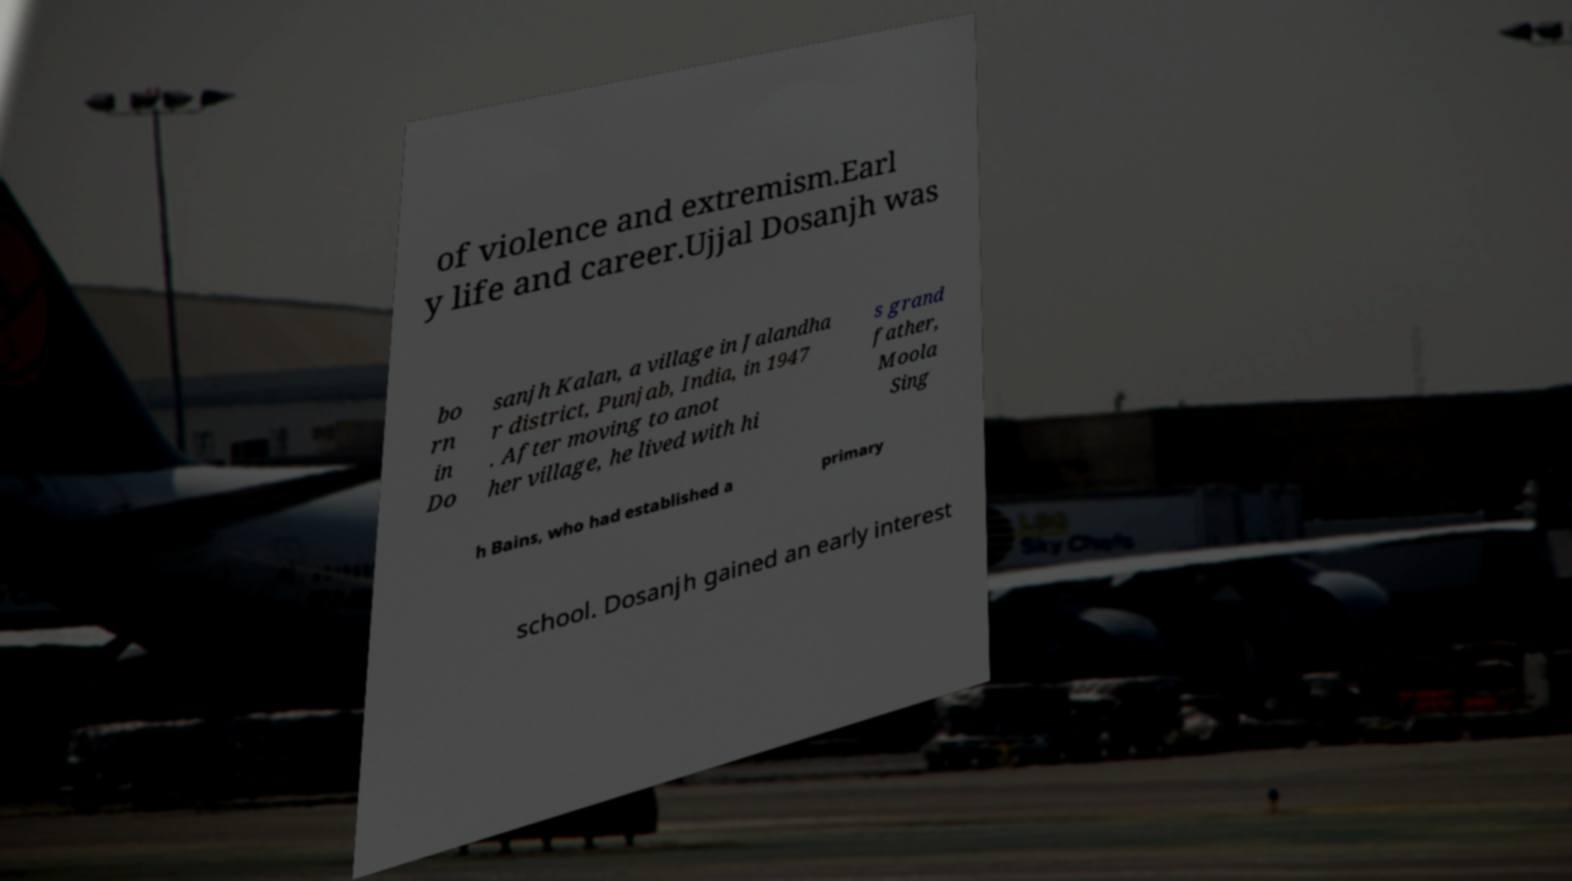Please read and relay the text visible in this image. What does it say? of violence and extremism.Earl y life and career.Ujjal Dosanjh was bo rn in Do sanjh Kalan, a village in Jalandha r district, Punjab, India, in 1947 . After moving to anot her village, he lived with hi s grand father, Moola Sing h Bains, who had established a primary school. Dosanjh gained an early interest 